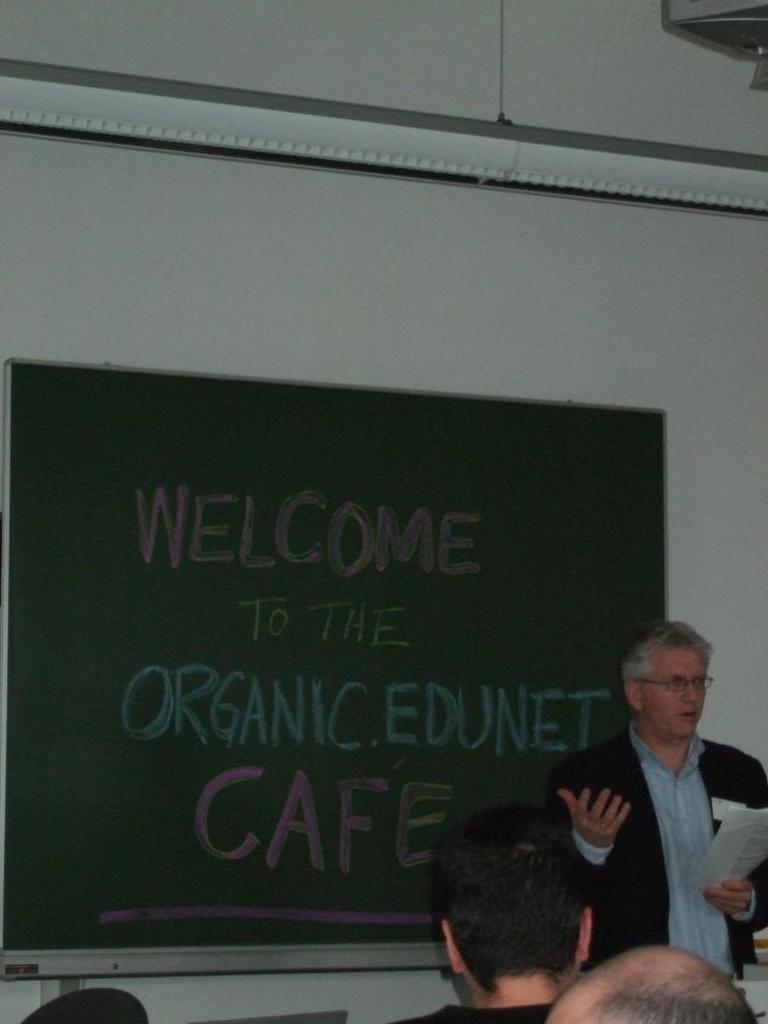What can be seen in the foreground of the picture? There are people in the foreground of the picture. What is located in the center of the picture? There is a board in the center of the picture. What is positioned at the top of the picture? There is a projector screen at the top of the picture. What type of structure is visible in the picture? There is a wall in the picture. How many teeth can be seen on the projector screen in the image? There are no teeth visible on the projector screen in the image. What is the distance between the people in the foreground and the wall in the picture? The distance between the people in the foreground and the wall cannot be determined from the image alone, as there is no reference point for scale. 